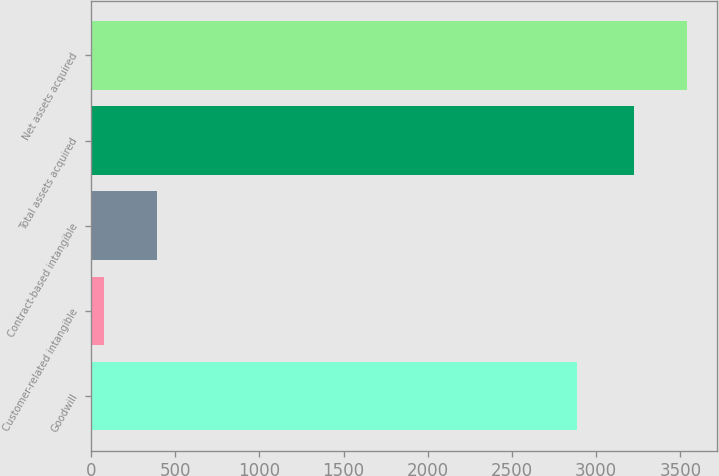Convert chart. <chart><loc_0><loc_0><loc_500><loc_500><bar_chart><fcel>Goodwill<fcel>Customer-related intangible<fcel>Contract-based intangible<fcel>Total assets acquired<fcel>Net assets acquired<nl><fcel>2887<fcel>78<fcel>392.8<fcel>3226<fcel>3540.8<nl></chart> 